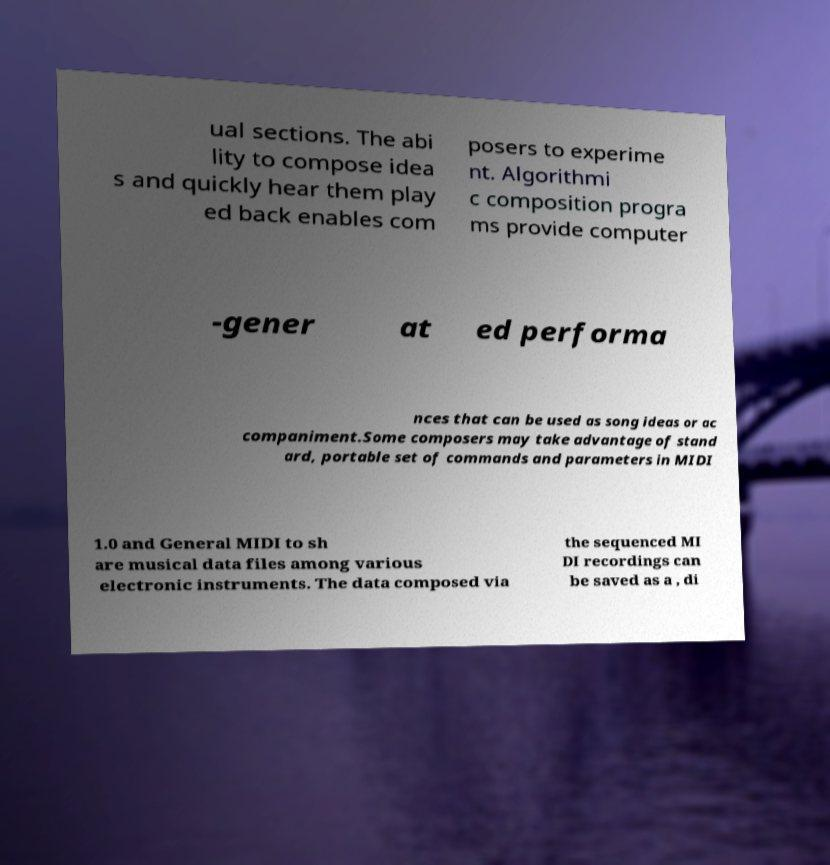Please read and relay the text visible in this image. What does it say? ual sections. The abi lity to compose idea s and quickly hear them play ed back enables com posers to experime nt. Algorithmi c composition progra ms provide computer -gener at ed performa nces that can be used as song ideas or ac companiment.Some composers may take advantage of stand ard, portable set of commands and parameters in MIDI 1.0 and General MIDI to sh are musical data files among various electronic instruments. The data composed via the sequenced MI DI recordings can be saved as a , di 